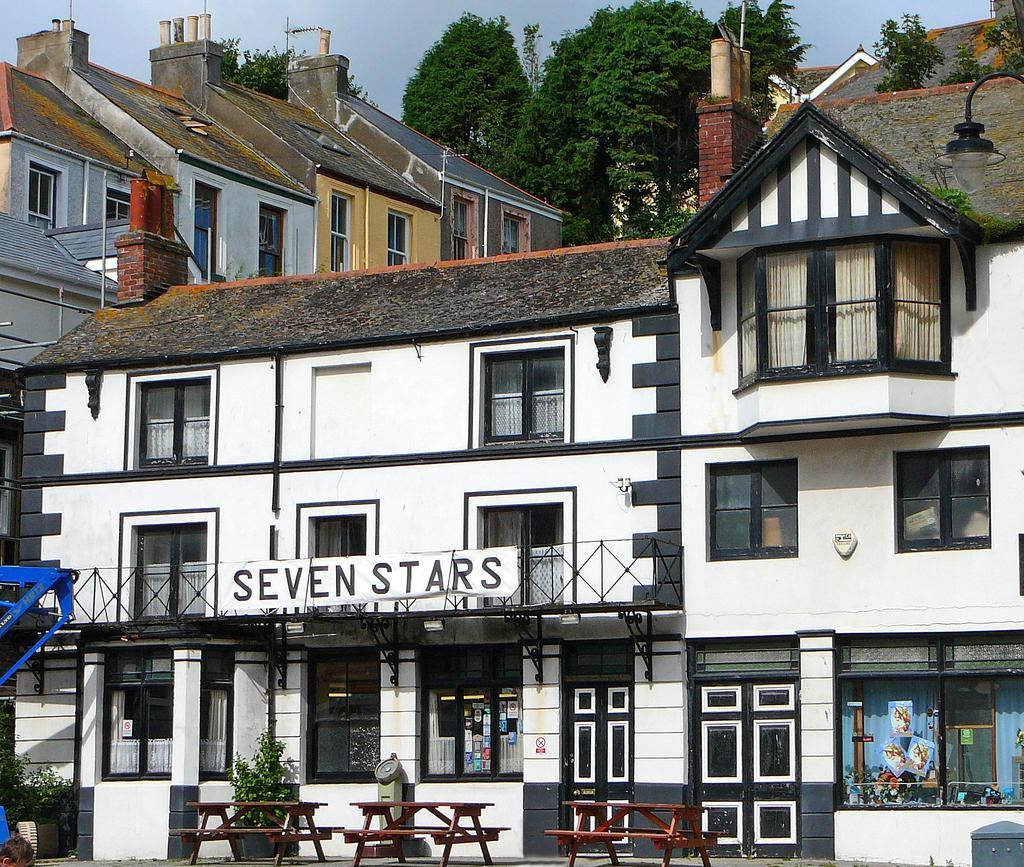Describe this image in one or two sentences. In this image we can see many buildings. And we can see the windows. And we can see the lights. And we can see the sky. And we can see the trees. And we can see the benches. And we can see some text written on the building. 